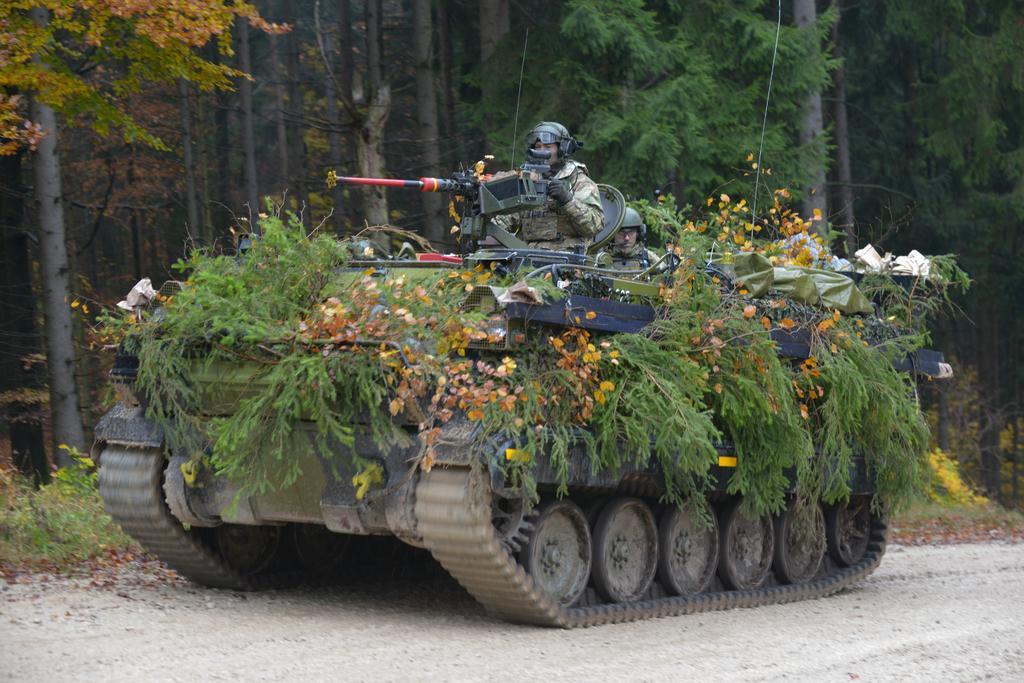What is the main subject of the image? The main subject of the image is an army tanker. How is the army tanker decorated in the image? The army tanker is decorated with flowers and leaves. What is the position of the army member in the image? There is an army member sitting on the army tanker. What type of tax can be seen being paid by the army tanker in the image? There is no indication of any tax being paid in the image; it features an army tanker decorated with flowers and leaves, with an army member sitting on it. Can you tell me how many toys are visible on the army tanker in the image? There are no toys visible on the army tanker in the image. 